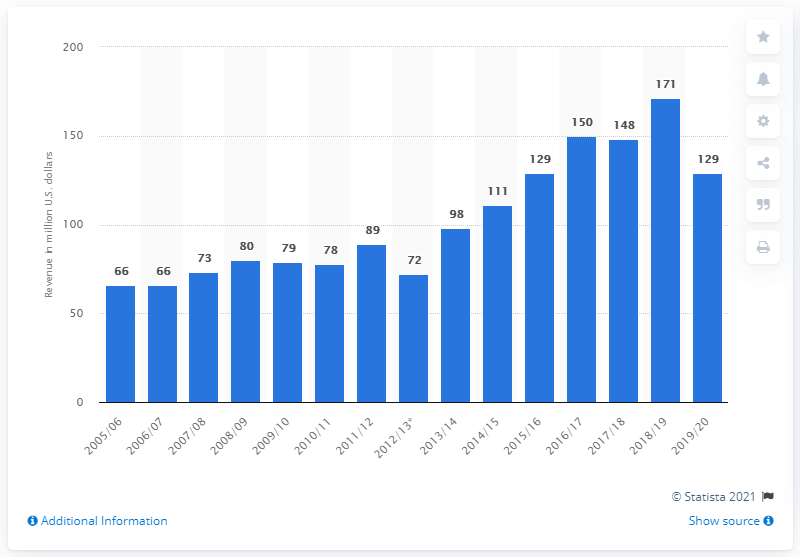Highlight a few significant elements in this photo. The revenue of the St. Louis Blues in the 2019/20 season was $129 million. 